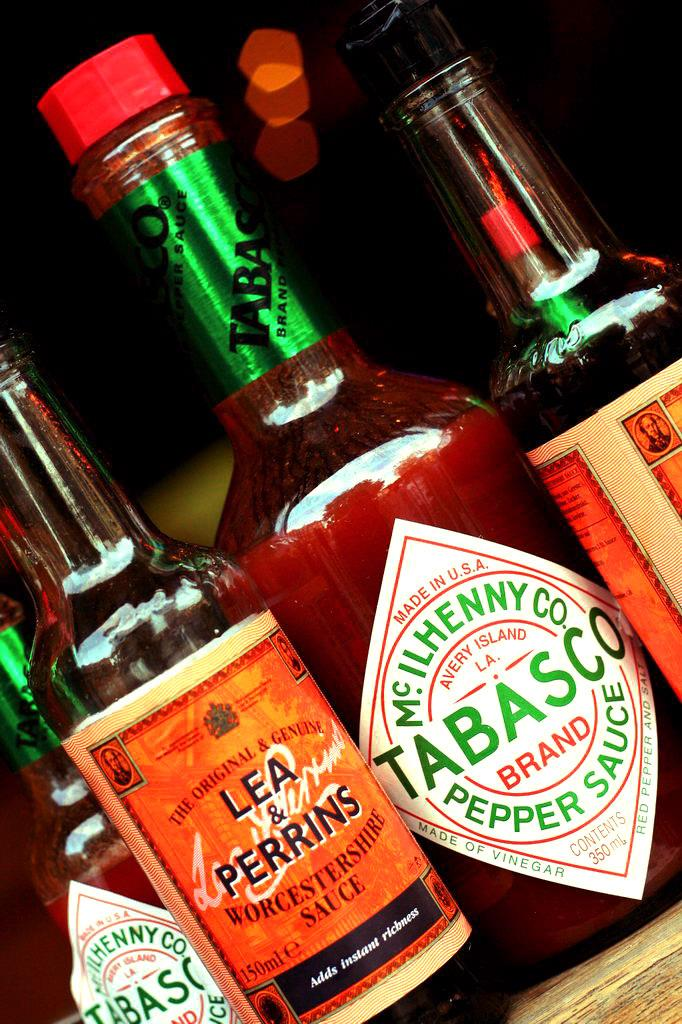<image>
Summarize the visual content of the image. A bottle of Tabasco is surrounded by other bottles. 